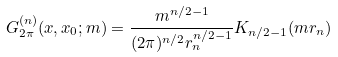Convert formula to latex. <formula><loc_0><loc_0><loc_500><loc_500>G _ { 2 \pi } ^ { ( n ) } ( x , x _ { 0 } ; m ) = \frac { m ^ { n / 2 - 1 } } { ( 2 \pi ) ^ { n / 2 } r _ { n } ^ { n / 2 - 1 } } K _ { n / 2 - 1 } ( m r _ { n } )</formula> 